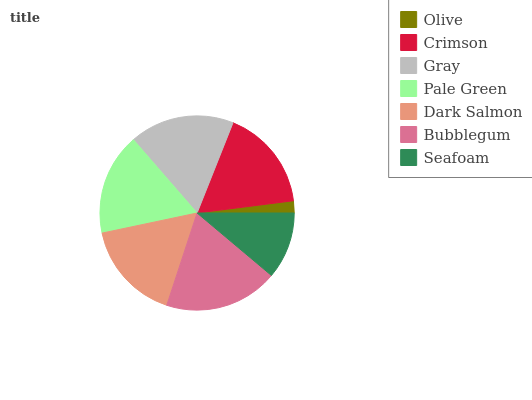Is Olive the minimum?
Answer yes or no. Yes. Is Bubblegum the maximum?
Answer yes or no. Yes. Is Crimson the minimum?
Answer yes or no. No. Is Crimson the maximum?
Answer yes or no. No. Is Crimson greater than Olive?
Answer yes or no. Yes. Is Olive less than Crimson?
Answer yes or no. Yes. Is Olive greater than Crimson?
Answer yes or no. No. Is Crimson less than Olive?
Answer yes or no. No. Is Pale Green the high median?
Answer yes or no. Yes. Is Pale Green the low median?
Answer yes or no. Yes. Is Dark Salmon the high median?
Answer yes or no. No. Is Dark Salmon the low median?
Answer yes or no. No. 